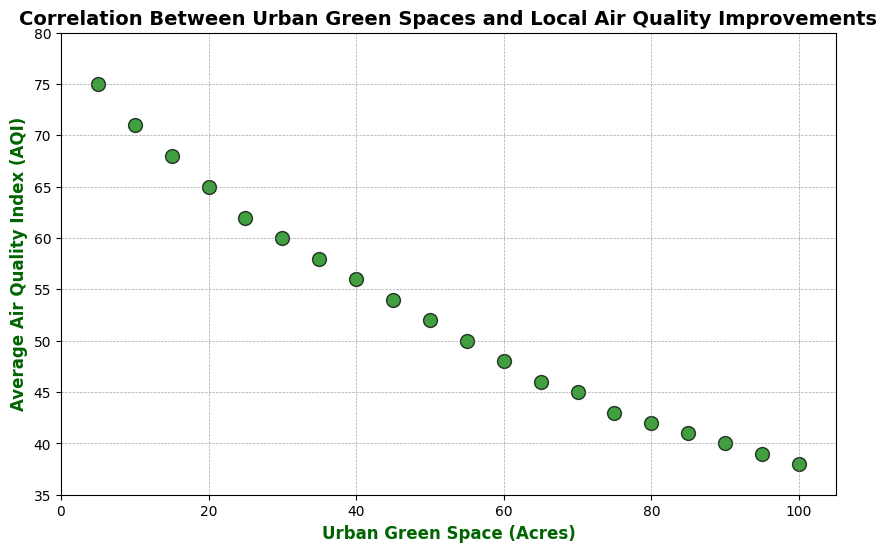What's the relationship between urban green space and AQI? As the urban green space (in acres) increases, the Average Air Quality Index (AQI) decreases, indicating an improvement in air quality. By observing the scatter plot trend, it's clear that larger green spaces correlate with better air quality.
Answer: Negative correlation How does the AQI change when urban green space increases from 10 acres to 40 acres? From the plot, the AQI decreases from 71 to 56 as urban green space increases from 10 to 40 acres.
Answer: Decreases by 15 What is the AQI for the smallest and largest urban green spaces on the plot? The smallest urban green space is 5 acres with an AQI of 75, and the largest is 100 acres with an AQI of 38.
Answer: 75 and 38 Which urban green space size corresponds to an AQI of 60? From the plot, an urban green space of approximately 30 acres corresponds to an AQI of 60.
Answer: 30 acres How much does the AQI reduce for every 10 additional acres of urban green space on average? Looking at the data for every 10 acres interval (e.g., 10 acres to 20 acres: AQI reduces by 6, 20 acres to 30 acres: AQI reduces by 5, etc.), we can generalize that the AQI reduces by approximately 6 units for every 10 additional acres of urban green space on average.
Answer: ~6 units Compare the AQI values for 25 acres and 75 acres of urban green space. For 25 acres, the AQI is 62, and for 75 acres, the AQI is 43. This means that the AQI is significantly lower for 75 acres of green space.
Answer: 62 vs 43 What is the visual difference in the markers for the lowest and highest urban green space sizes? There is no visual difference in color; all markers are green with black edges. The markers for the lowest urban green space sized circle appear at the higher end of the vertical axis (higher AQI), and for the highest urban green space appear at the lower end of the vertical axis (lower AQI).
Answer: Higher versus lower on vertical axis Estimate the AQI for an urban green space of 50 acres based on the plot. From the plot, an urban green space of 50 acres corresponds roughly to an AQI of 52.
Answer: ~52 What can you infer about the scatter plot's trend if urban green space is doubled from 20 to 40 acres? As urban green space doubles from 20 acres to 40 acres, the AQI decreases from 65 to 56, implying a 9-point reduction, demonstrating that increasing green space results in better air quality.
Answer: 56 vs 65 